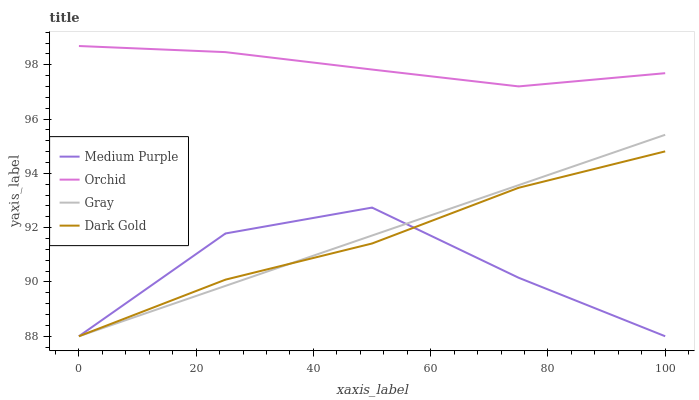Does Medium Purple have the minimum area under the curve?
Answer yes or no. Yes. Does Orchid have the maximum area under the curve?
Answer yes or no. Yes. Does Gray have the minimum area under the curve?
Answer yes or no. No. Does Gray have the maximum area under the curve?
Answer yes or no. No. Is Gray the smoothest?
Answer yes or no. Yes. Is Medium Purple the roughest?
Answer yes or no. Yes. Is Dark Gold the smoothest?
Answer yes or no. No. Is Dark Gold the roughest?
Answer yes or no. No. Does Medium Purple have the lowest value?
Answer yes or no. Yes. Does Orchid have the lowest value?
Answer yes or no. No. Does Orchid have the highest value?
Answer yes or no. Yes. Does Gray have the highest value?
Answer yes or no. No. Is Gray less than Orchid?
Answer yes or no. Yes. Is Orchid greater than Dark Gold?
Answer yes or no. Yes. Does Dark Gold intersect Medium Purple?
Answer yes or no. Yes. Is Dark Gold less than Medium Purple?
Answer yes or no. No. Is Dark Gold greater than Medium Purple?
Answer yes or no. No. Does Gray intersect Orchid?
Answer yes or no. No. 